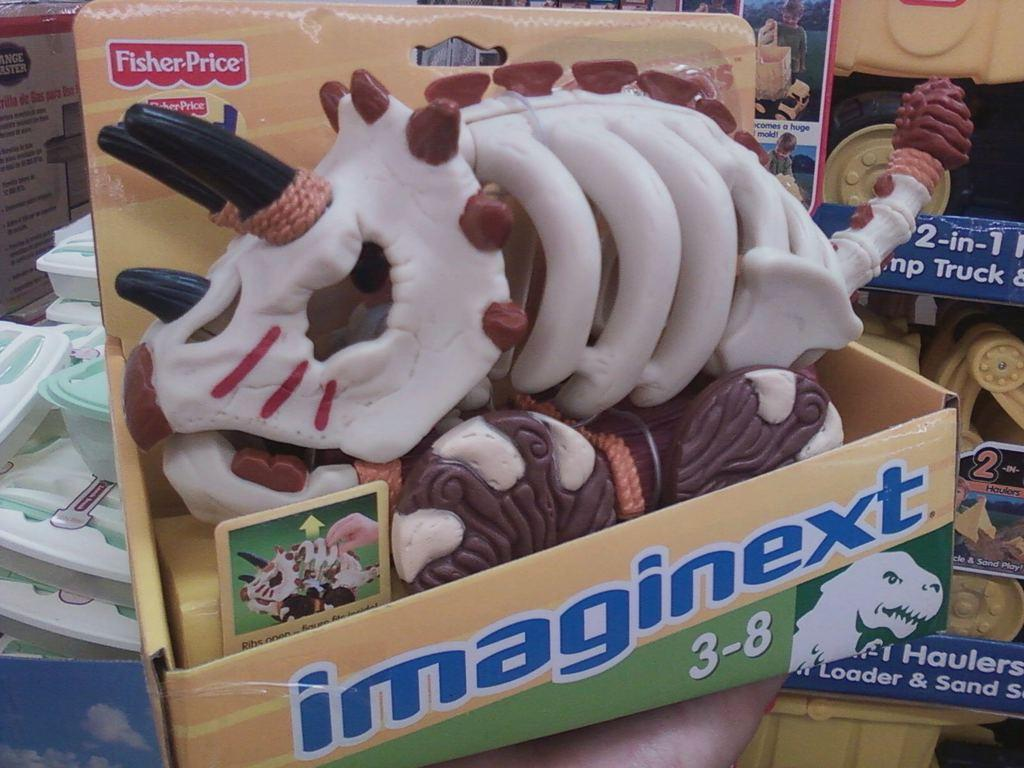What is the person holding in the image? There is a person's hand holding a card box in the image. What is inside the card box? The card box contains toys. What is the surface on which the card box and other items are placed? There is a table in the image. What other items can be seen on the table? Other boxes and toys are placed on the table. What story is the squirrel telling on the table in the image? There is no squirrel present in the image, and therefore no story being told. 